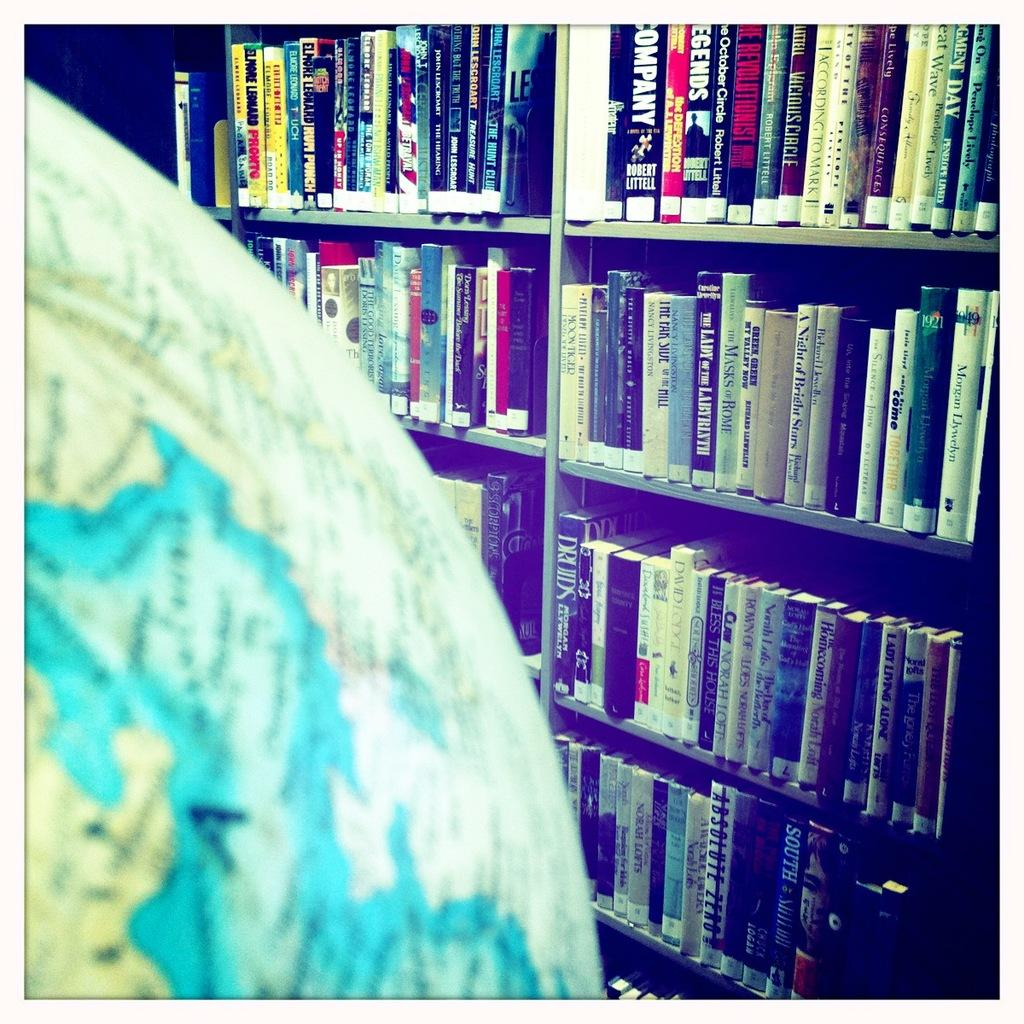<image>
Render a clear and concise summary of the photo. An atlas is next to a bookshelf full of books including The Lady of the Labyrinth. 